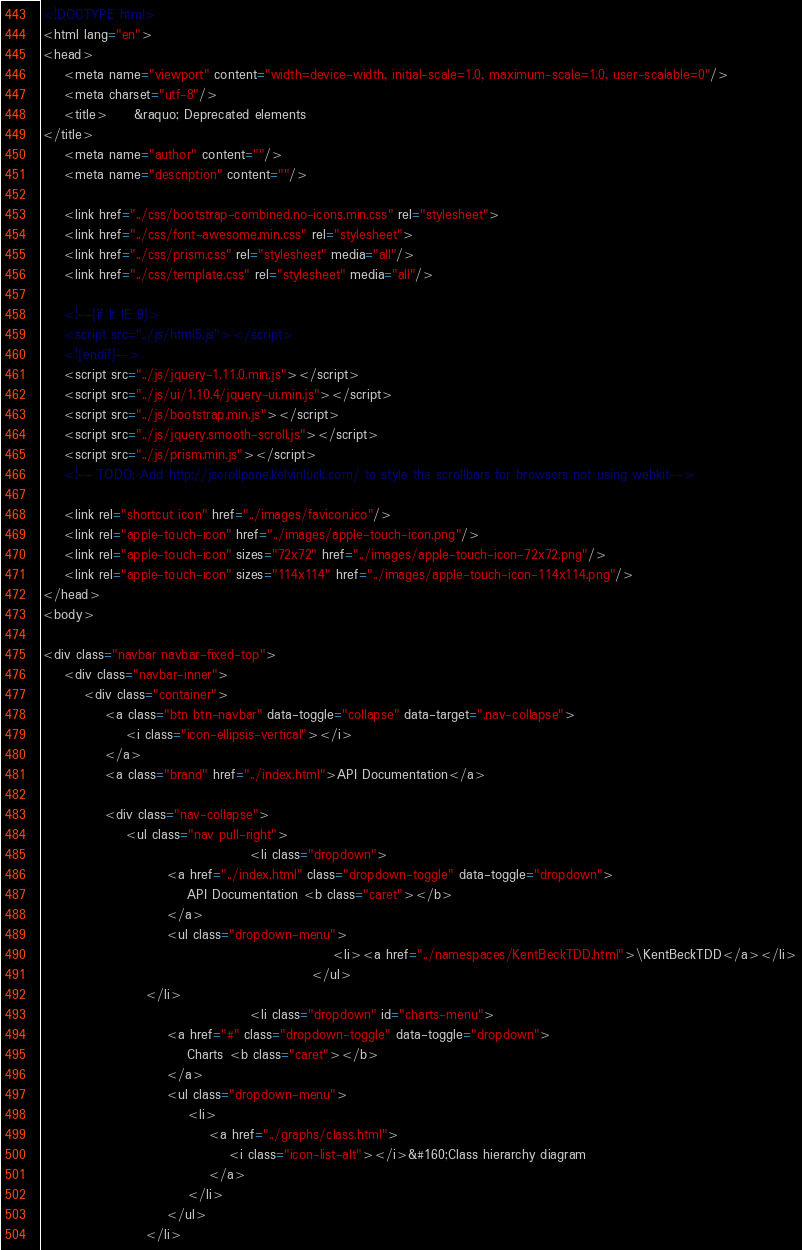<code> <loc_0><loc_0><loc_500><loc_500><_HTML_><!DOCTYPE html>
<html lang="en">
<head>
    <meta name="viewport" content="width=device-width, initial-scale=1.0, maximum-scale=1.0, user-scalable=0"/>
    <meta charset="utf-8"/>
    <title>     &raquo; Deprecated elements
</title>
    <meta name="author" content=""/>
    <meta name="description" content=""/>

    <link href="../css/bootstrap-combined.no-icons.min.css" rel="stylesheet">
    <link href="../css/font-awesome.min.css" rel="stylesheet">
    <link href="../css/prism.css" rel="stylesheet" media="all"/>
    <link href="../css/template.css" rel="stylesheet" media="all"/>
    
    <!--[if lt IE 9]>
    <script src="../js/html5.js"></script>
    <![endif]-->
    <script src="../js/jquery-1.11.0.min.js"></script>
    <script src="../js/ui/1.10.4/jquery-ui.min.js"></script>
    <script src="../js/bootstrap.min.js"></script>
    <script src="../js/jquery.smooth-scroll.js"></script>
    <script src="../js/prism.min.js"></script>
    <!-- TODO: Add http://jscrollpane.kelvinluck.com/ to style the scrollbars for browsers not using webkit-->
    
    <link rel="shortcut icon" href="../images/favicon.ico"/>
    <link rel="apple-touch-icon" href="../images/apple-touch-icon.png"/>
    <link rel="apple-touch-icon" sizes="72x72" href="../images/apple-touch-icon-72x72.png"/>
    <link rel="apple-touch-icon" sizes="114x114" href="../images/apple-touch-icon-114x114.png"/>
</head>
<body>

<div class="navbar navbar-fixed-top">
    <div class="navbar-inner">
        <div class="container">
            <a class="btn btn-navbar" data-toggle="collapse" data-target=".nav-collapse">
                <i class="icon-ellipsis-vertical"></i>
            </a>
            <a class="brand" href="../index.html">API Documentation</a>

            <div class="nav-collapse">
                <ul class="nav pull-right">
                                        <li class="dropdown">
                        <a href="../index.html" class="dropdown-toggle" data-toggle="dropdown">
                            API Documentation <b class="caret"></b>
                        </a>
                        <ul class="dropdown-menu">
                                                        <li><a href="../namespaces/KentBeckTDD.html">\KentBeckTDD</a></li>
                                                    </ul>
                    </li>
                                        <li class="dropdown" id="charts-menu">
                        <a href="#" class="dropdown-toggle" data-toggle="dropdown">
                            Charts <b class="caret"></b>
                        </a>
                        <ul class="dropdown-menu">
                            <li>
                                <a href="../graphs/class.html">
                                    <i class="icon-list-alt"></i>&#160;Class hierarchy diagram
                                </a>
                            </li>
                        </ul>
                    </li></code> 